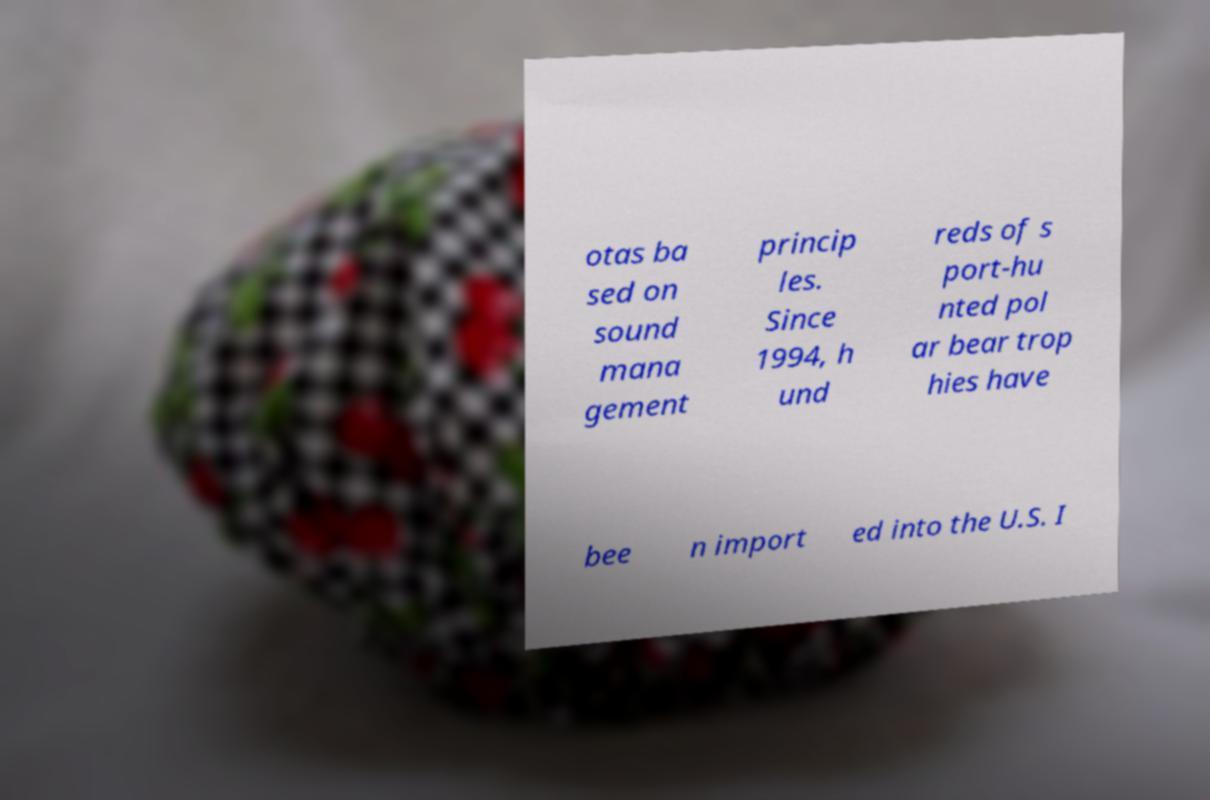For documentation purposes, I need the text within this image transcribed. Could you provide that? otas ba sed on sound mana gement princip les. Since 1994, h und reds of s port-hu nted pol ar bear trop hies have bee n import ed into the U.S. I 